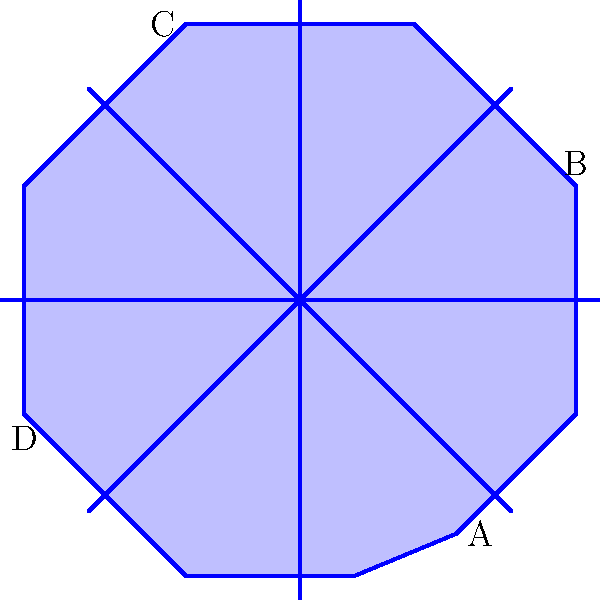In the geometric pattern above, inspired by the designs found on historical buildings in Karaman, ABCD forms a rectangle. If $\overline{AB} \cong \overline{BC}$, which of the following congruence statements is true? Let's approach this step-by-step:

1) We are given that ABCD is a rectangle. In a rectangle, opposite sides are congruent and all angles are right angles.

2) We are also told that $\overline{AB} \cong \overline{BC}$. This means that all sides of the rectangle are congruent.

3) When all sides of a rectangle are congruent, it becomes a square.

4) In a square:
   - All sides are congruent
   - All angles are right angles
   - Diagonals are congruent and bisect each other

5) Therefore, we can conclude that:
   - $\overline{AB} \cong \overline{BC} \cong \overline{CD} \cong \overline{DA}$
   - $\angle ABC \cong \angle BCD \cong \angle CDA \cong \angle DAB$
   - $\overline{AC} \cong \overline{BD}$ (diagonals)

6) Among these, the congruence of diagonals ($\overline{AC} \cong \overline{BD}$) is the most specific to a square and not true for all rectangles.
Answer: $\overline{AC} \cong \overline{BD}$ 